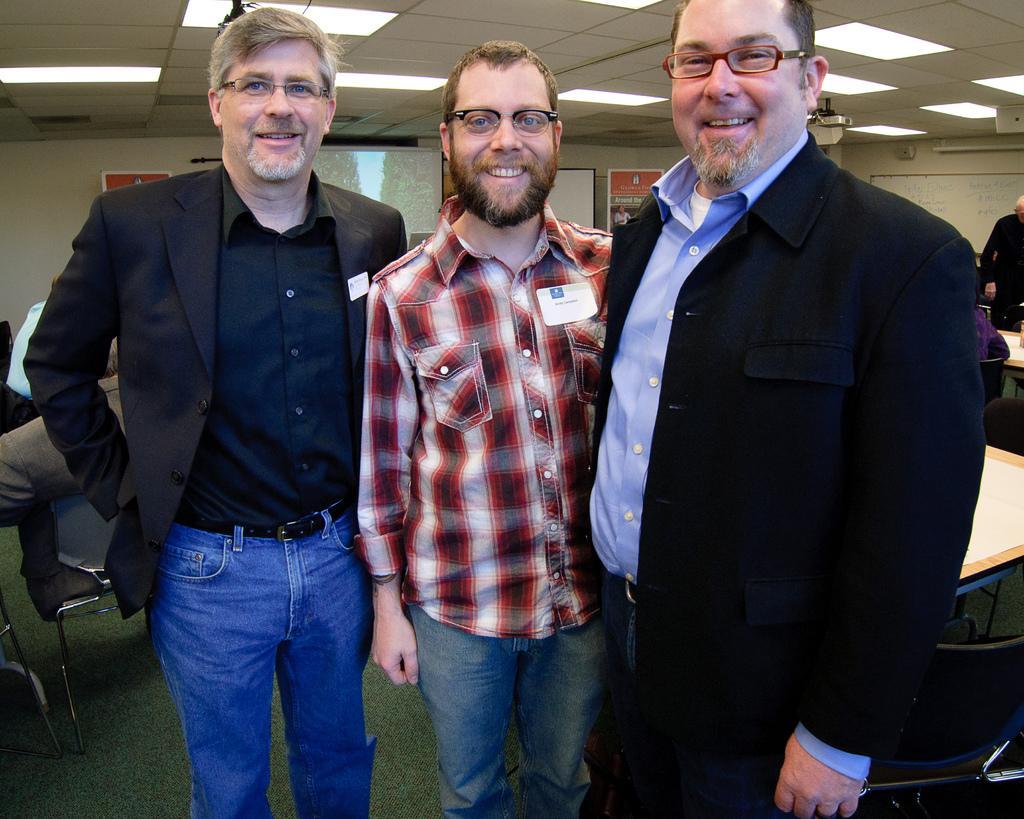Could you give a brief overview of what you see in this image? In this picture I can see three persons standing and smiling, there are group of people, there are chairs, tables, lights, boards, and in the background there is a screen and a projector. 